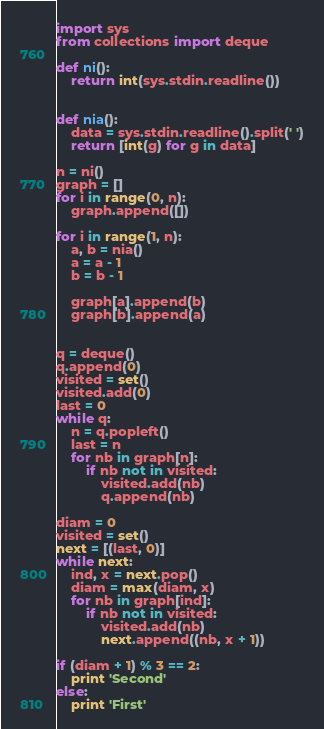<code> <loc_0><loc_0><loc_500><loc_500><_Python_>import sys
from collections import deque

def ni():
    return int(sys.stdin.readline())


def nia():
    data = sys.stdin.readline().split(' ')
    return [int(g) for g in data]

n = ni()
graph = []
for i in range(0, n):
    graph.append([])

for i in range(1, n):
    a, b = nia()
    a = a - 1
    b = b - 1

    graph[a].append(b)
    graph[b].append(a)


q = deque()
q.append(0)
visited = set()
visited.add(0)
last = 0
while q:
    n = q.popleft()
    last = n
    for nb in graph[n]:
        if nb not in visited:
            visited.add(nb)
            q.append(nb)

diam = 0
visited = set()
next = [(last, 0)]
while next:
    ind, x = next.pop()
    diam = max(diam, x)
    for nb in graph[ind]:
        if nb not in visited:
            visited.add(nb)
            next.append((nb, x + 1))

if (diam + 1) % 3 == 2:
    print 'Second'
else:
    print 'First'

</code> 